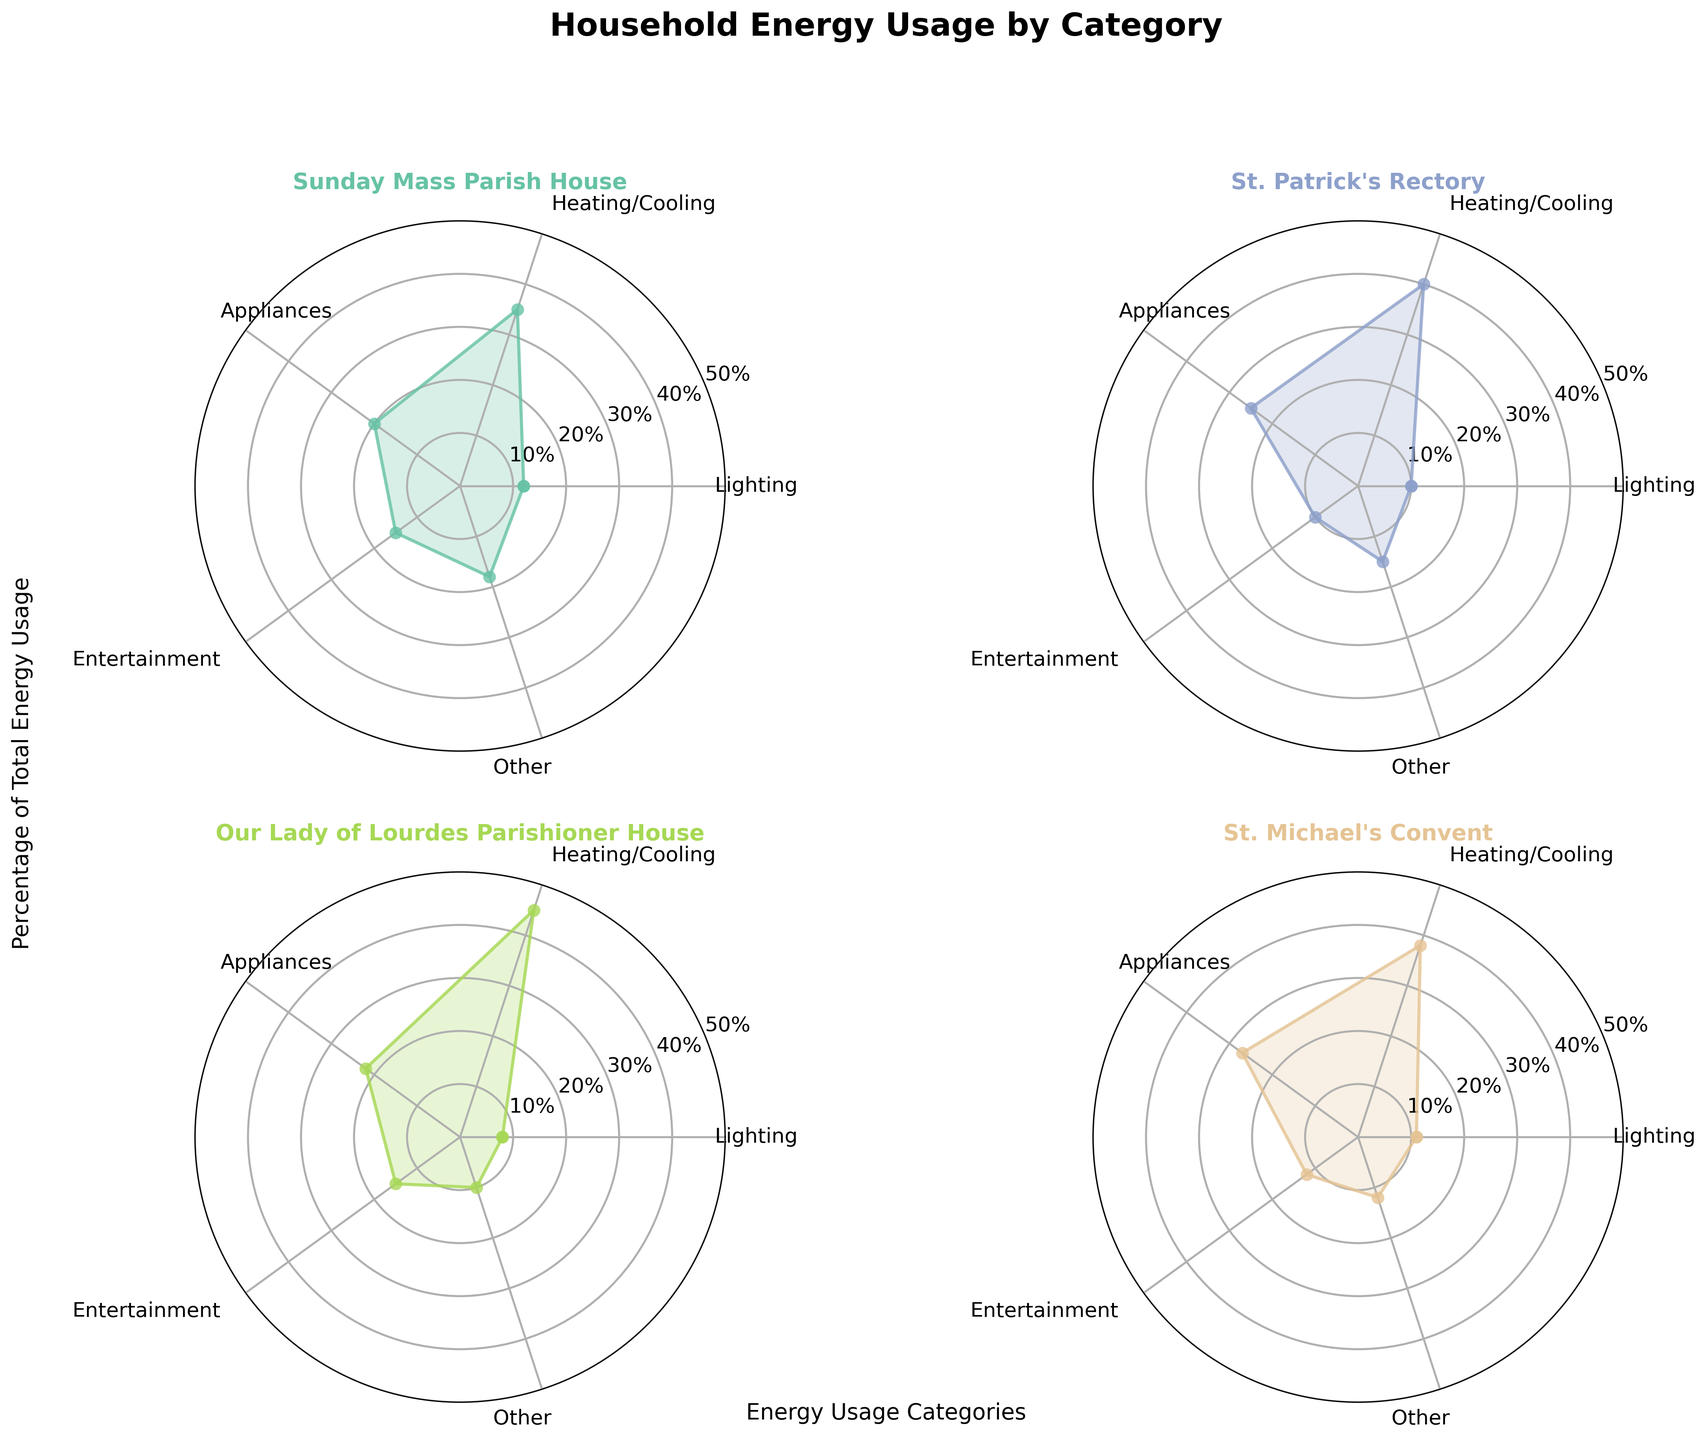How many different categories of energy usage are shown on each subplot? Each radar chart (subplot) has five different categories of energy usage displayed: Lighting, Heating/Cooling, Appliances, Entertainment, and Other.
Answer: Five Which household has the highest percentage usage for Heating/Cooling? By looking at the highest points for Heating/Cooling on each radar chart, Our Lady of Lourdes Parishioner House has the highest with 45%.
Answer: Our Lady of Lourdes Parishioner House What is the average percentage usage of Lighting across all households? The percentages for Lighting are 12, 10, 8, and 11. Add these values to get 41 and then divide by 4 to get the average: 41/4 = 10.25%.
Answer: 10.25% Which household has the lowest percentage usage for Appliances? By observing the radar charts, the Sunday Mass Parish House has the lowest usage for Appliances at 20%.
Answer: Sunday Mass Parish House Compare the percentage usage of Entertainment between St. Patrick's Rectory and St. Michael's Convent. Which one is higher? The percentage usage for Entertainment at St. Patrick's Rectory is 10%, while at St. Michael's Convent, it is 12%. St. Michael's Convent is higher.
Answer: St. Michael's Convent In the Sunday Mass Parish House, how much more energy is used for Heating/Cooling compared to Lighting? The percentage for Heating/Cooling is 35% and for Lighting is 12%. The difference is 35% - 12% = 23%.
Answer: 23% What is the total percentage usage for Other across all households? Add the percentages for Other from each household: 18 (Sunday Mass Parish House) + 15 (St. Patrick's Rectory) + 10 (Our Lady of Lourdes Parishioner House) + 12 (St. Michael's Convent) = 55%.
Answer: 55% Which household shows the least variation in energy usage percentages across different categories? By visually inspecting the radar charts, St. Michael's Convent shows the most balanced energy usage distribution without dramatic spikes or drops.
Answer: St. Michael's Convent What is the median percentage usage for Appliances across all households? The values for Appliances are 20, 25, 22, 27. When sorted, they are 20, 22, 25, 27. The median is the average of the two middle numbers: (22 + 25) / 2 = 23.5%.
Answer: 23.5% 